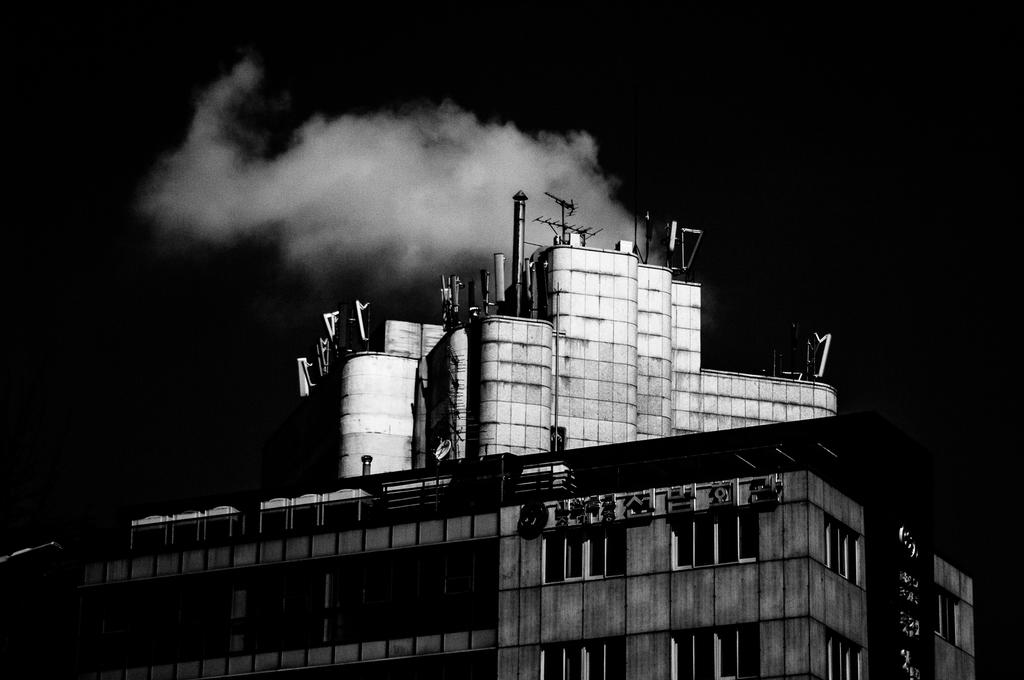What is the color scheme of the image? The picture is black and white. What can be seen in the image? There is a factory in the image. What is the factory doing in the image? The factory is releasing gases. Can you see the moon in the image? There is no moon visible in the image; it is a black and white picture of a factory releasing gases. What type of tool is being used to harvest the celery in the image? There is no celery or tool present in the image; it features a factory releasing gases. 